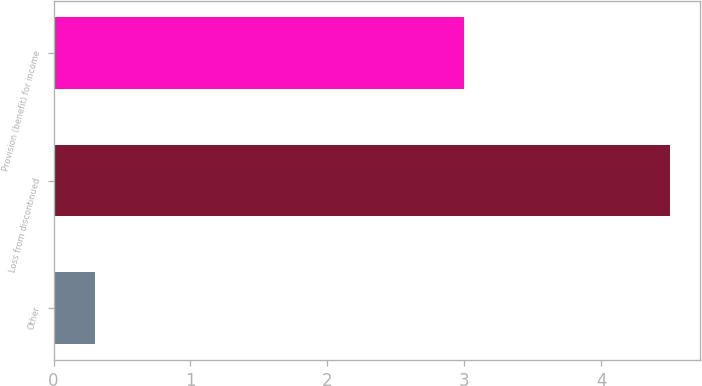Convert chart to OTSL. <chart><loc_0><loc_0><loc_500><loc_500><bar_chart><fcel>Other<fcel>Loss from discontinued<fcel>Provision (benefit) for income<nl><fcel>0.3<fcel>4.5<fcel>3<nl></chart> 